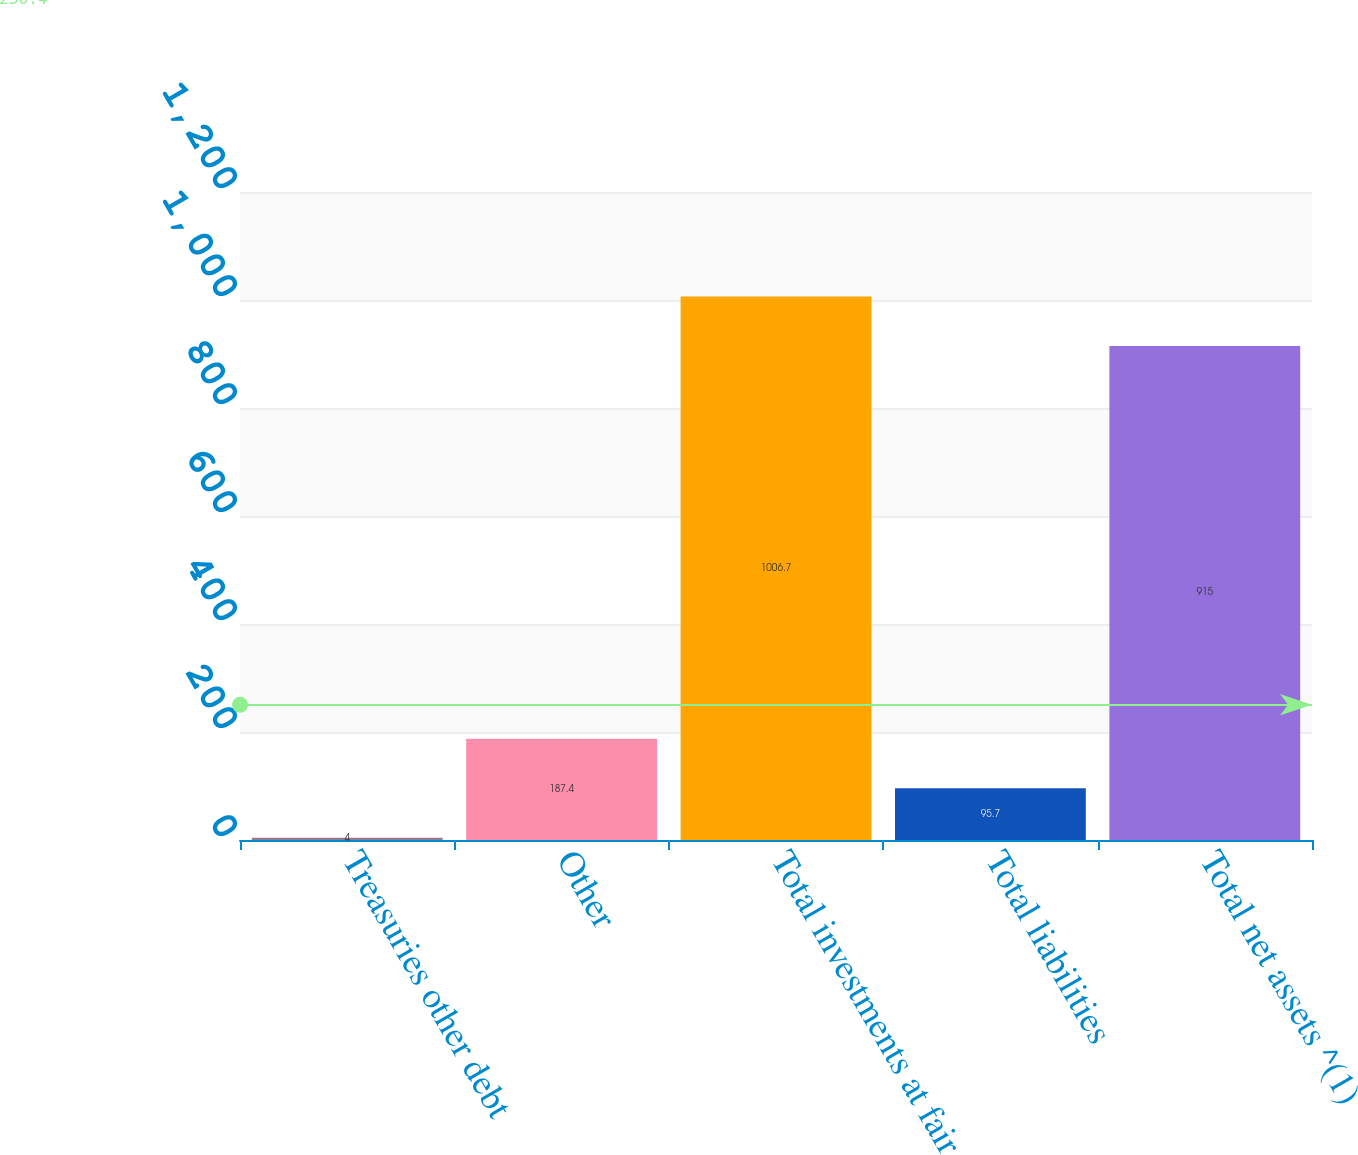Convert chart to OTSL. <chart><loc_0><loc_0><loc_500><loc_500><bar_chart><fcel>Treasuries other debt<fcel>Other<fcel>Total investments at fair<fcel>Total liabilities<fcel>Total net assets ^(1)<nl><fcel>4<fcel>187.4<fcel>1006.7<fcel>95.7<fcel>915<nl></chart> 